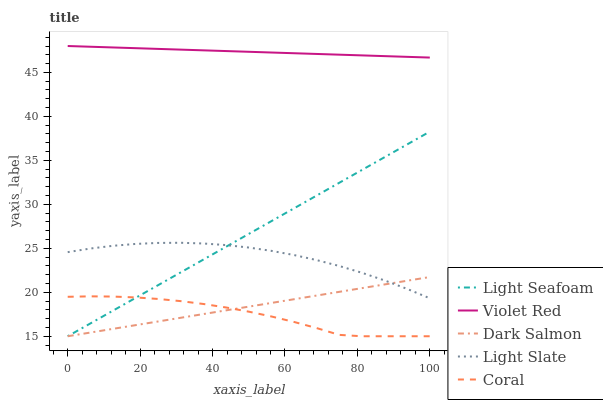Does Coral have the minimum area under the curve?
Answer yes or no. Yes. Does Violet Red have the maximum area under the curve?
Answer yes or no. Yes. Does Light Seafoam have the minimum area under the curve?
Answer yes or no. No. Does Light Seafoam have the maximum area under the curve?
Answer yes or no. No. Is Dark Salmon the smoothest?
Answer yes or no. Yes. Is Coral the roughest?
Answer yes or no. Yes. Is Violet Red the smoothest?
Answer yes or no. No. Is Violet Red the roughest?
Answer yes or no. No. Does Light Seafoam have the lowest value?
Answer yes or no. Yes. Does Violet Red have the lowest value?
Answer yes or no. No. Does Violet Red have the highest value?
Answer yes or no. Yes. Does Light Seafoam have the highest value?
Answer yes or no. No. Is Light Slate less than Violet Red?
Answer yes or no. Yes. Is Violet Red greater than Light Seafoam?
Answer yes or no. Yes. Does Light Slate intersect Dark Salmon?
Answer yes or no. Yes. Is Light Slate less than Dark Salmon?
Answer yes or no. No. Is Light Slate greater than Dark Salmon?
Answer yes or no. No. Does Light Slate intersect Violet Red?
Answer yes or no. No. 